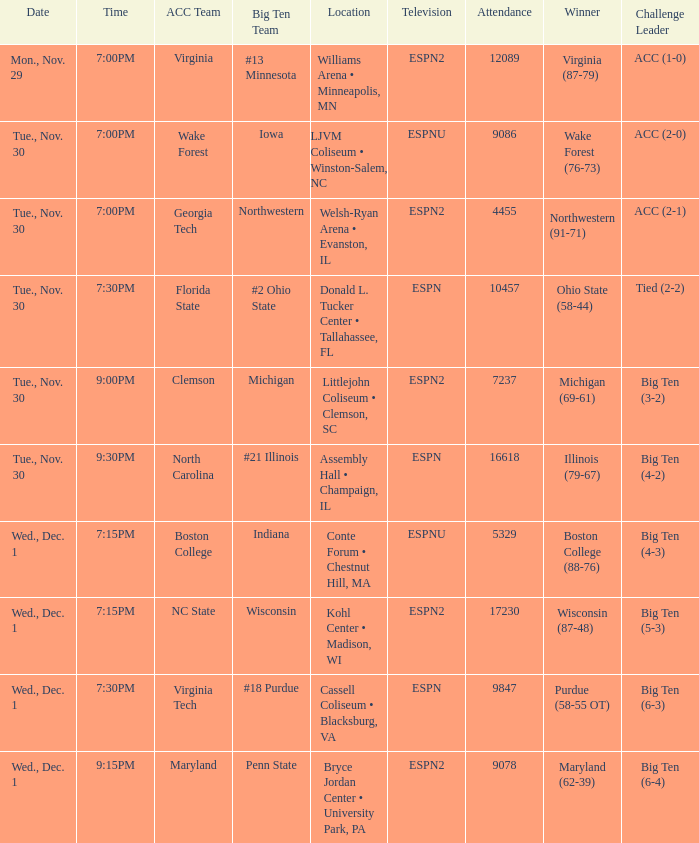What was the time of the games that took place at the cassell coliseum • blacksburg, va? 7:30PM. 